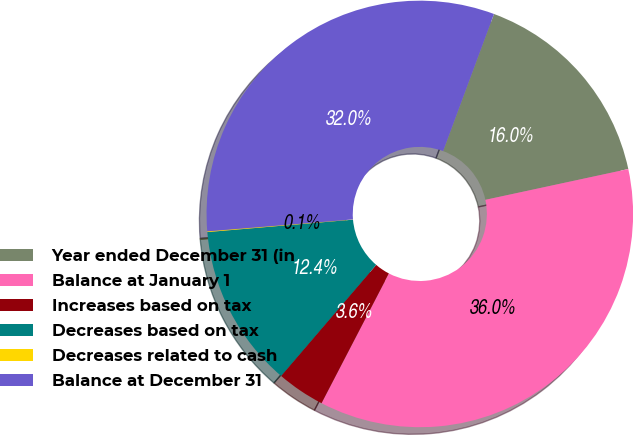Convert chart to OTSL. <chart><loc_0><loc_0><loc_500><loc_500><pie_chart><fcel>Year ended December 31 (in<fcel>Balance at January 1<fcel>Increases based on tax<fcel>Decreases based on tax<fcel>Decreases related to cash<fcel>Balance at December 31<nl><fcel>15.97%<fcel>36.0%<fcel>3.65%<fcel>12.37%<fcel>0.06%<fcel>31.95%<nl></chart> 